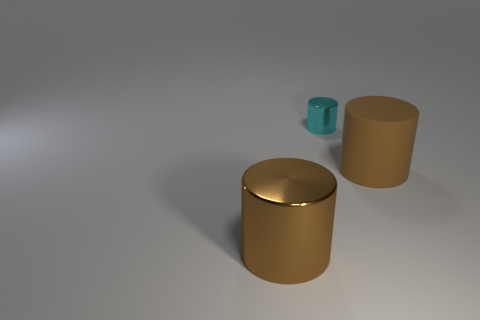What number of cubes are either brown things or small cyan metallic objects?
Offer a very short reply. 0. Are there any things that are left of the brown object that is to the right of the large brown metal object?
Your answer should be compact. Yes. Are there any other things that are made of the same material as the small thing?
Give a very brief answer. Yes. Is the shape of the large rubber object the same as the metallic thing that is behind the large metallic thing?
Provide a succinct answer. Yes. How many other objects are the same size as the rubber object?
Your answer should be very brief. 1. What number of cyan things are cylinders or large metallic things?
Provide a succinct answer. 1. How many large brown objects are both left of the small cyan thing and on the right side of the small cyan cylinder?
Provide a succinct answer. 0. The big thing that is behind the brown cylinder that is in front of the thing that is to the right of the tiny shiny thing is made of what material?
Your answer should be compact. Rubber. What number of cylinders have the same material as the cyan thing?
Your answer should be compact. 1. What shape is the big object that is the same color as the large rubber cylinder?
Keep it short and to the point. Cylinder. 